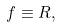<formula> <loc_0><loc_0><loc_500><loc_500>f \equiv R ,</formula> 